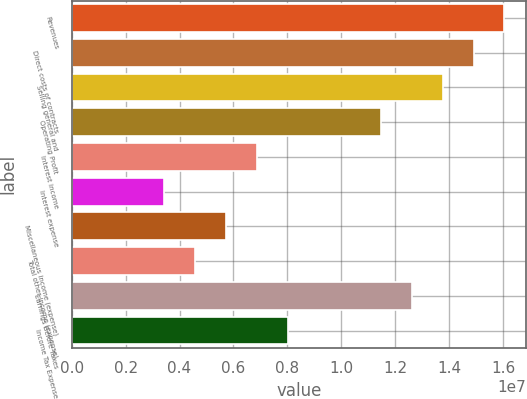<chart> <loc_0><loc_0><loc_500><loc_500><bar_chart><fcel>Revenues<fcel>Direct costs of contracts<fcel>Selling general and<fcel>Operating Profit<fcel>Interest income<fcel>Interest expense<fcel>Miscellaneous income (expense)<fcel>Total other income (expense)<fcel>Earnings Before Taxes<fcel>Income Tax Expense<nl><fcel>1.60543e+07<fcel>1.49076e+07<fcel>1.37609e+07<fcel>1.14674e+07<fcel>6.88043e+06<fcel>3.44022e+06<fcel>5.73369e+06<fcel>4.58695e+06<fcel>1.26141e+07<fcel>8.02716e+06<nl></chart> 